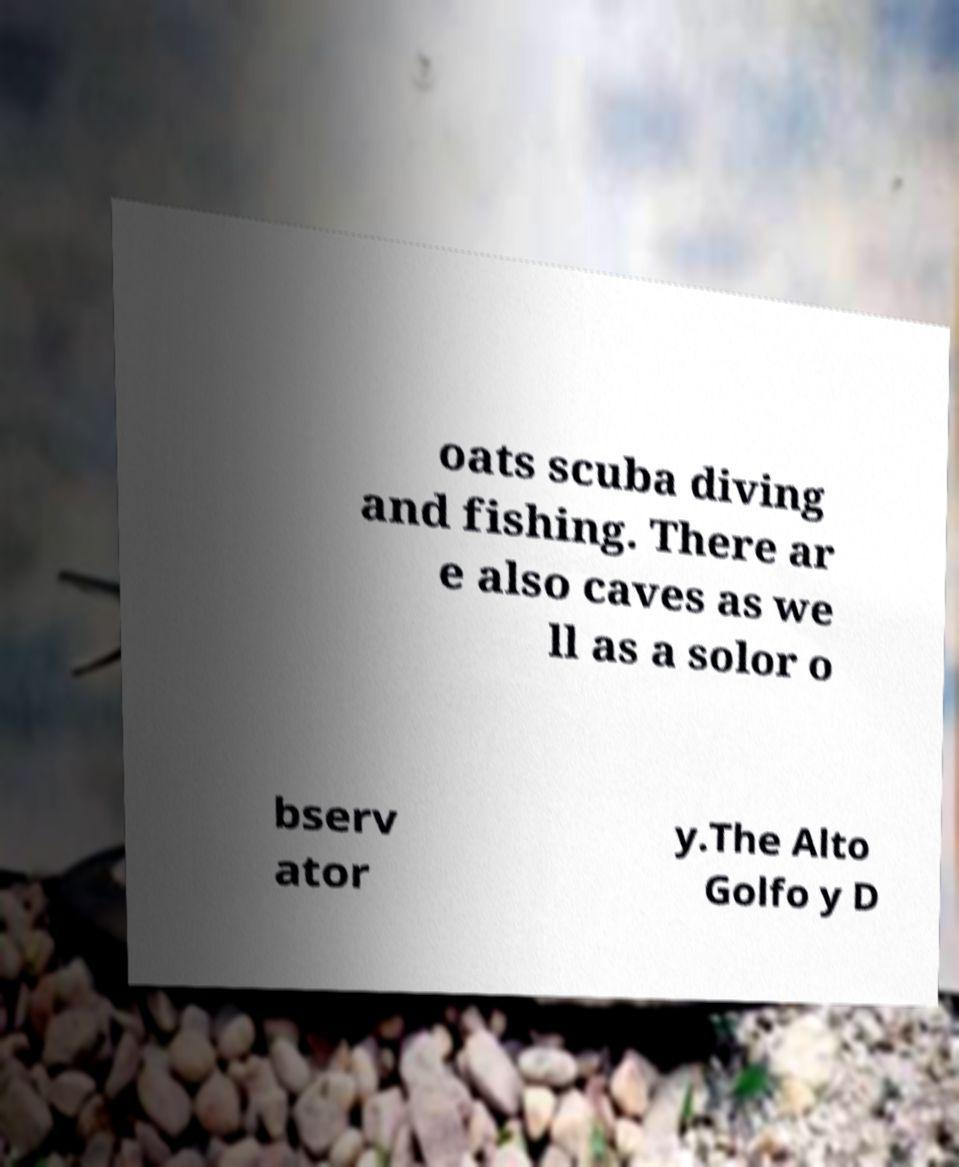There's text embedded in this image that I need extracted. Can you transcribe it verbatim? oats scuba diving and fishing. There ar e also caves as we ll as a solor o bserv ator y.The Alto Golfo y D 